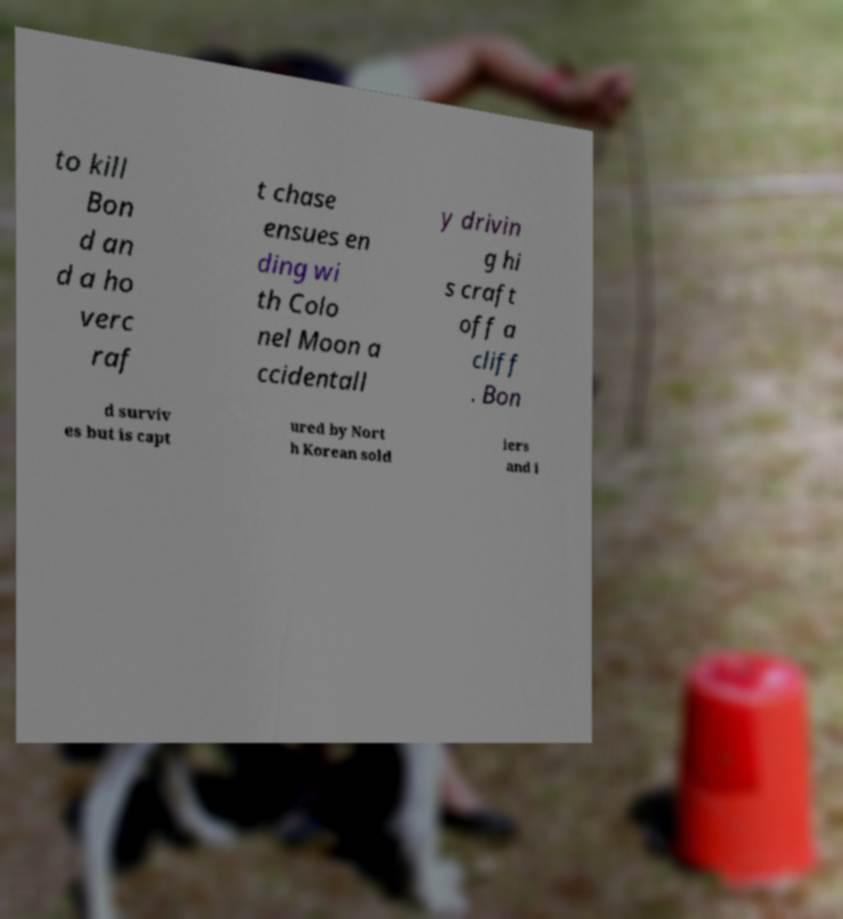Please read and relay the text visible in this image. What does it say? to kill Bon d an d a ho verc raf t chase ensues en ding wi th Colo nel Moon a ccidentall y drivin g hi s craft off a cliff . Bon d surviv es but is capt ured by Nort h Korean sold iers and i 